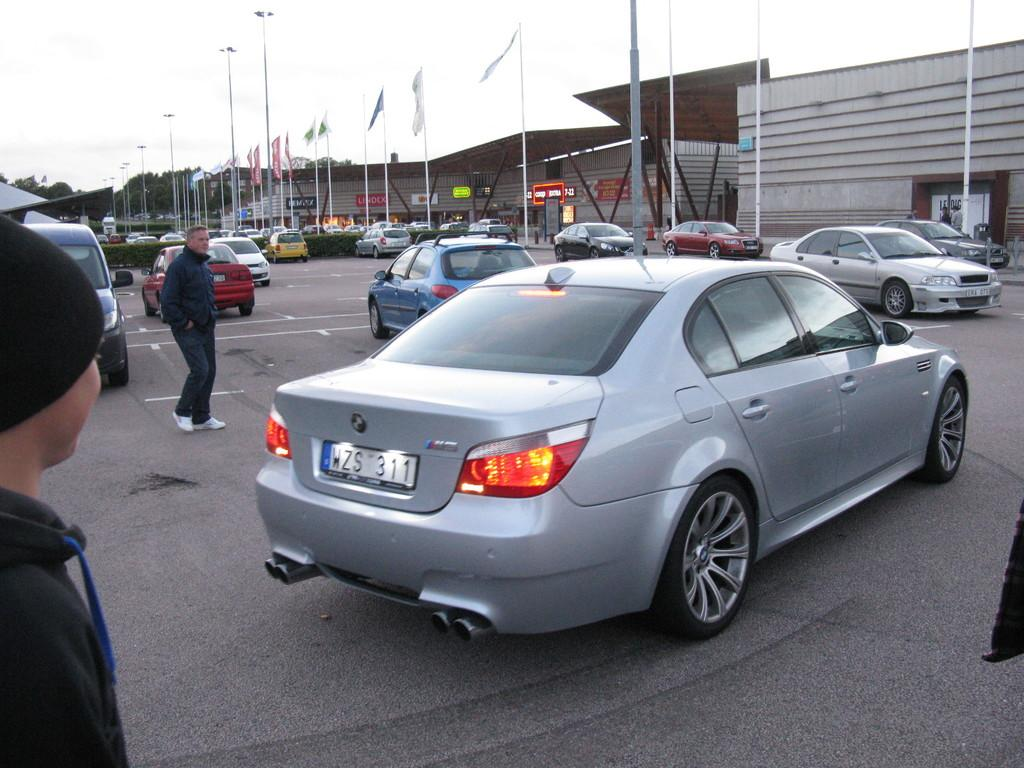<image>
Summarize the visual content of the image. A silver car with the license plate WZS 311 drives through a parking lot full of cars and people. 